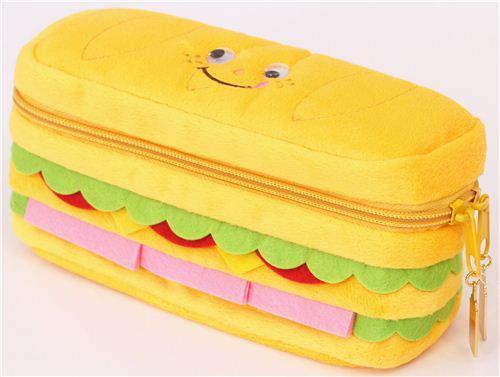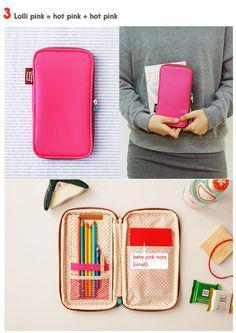The first image is the image on the left, the second image is the image on the right. For the images displayed, is the sentence "There is one yellow pencil case with an additional 3 to 4 different colors cases visible." factually correct? Answer yes or no. No. 